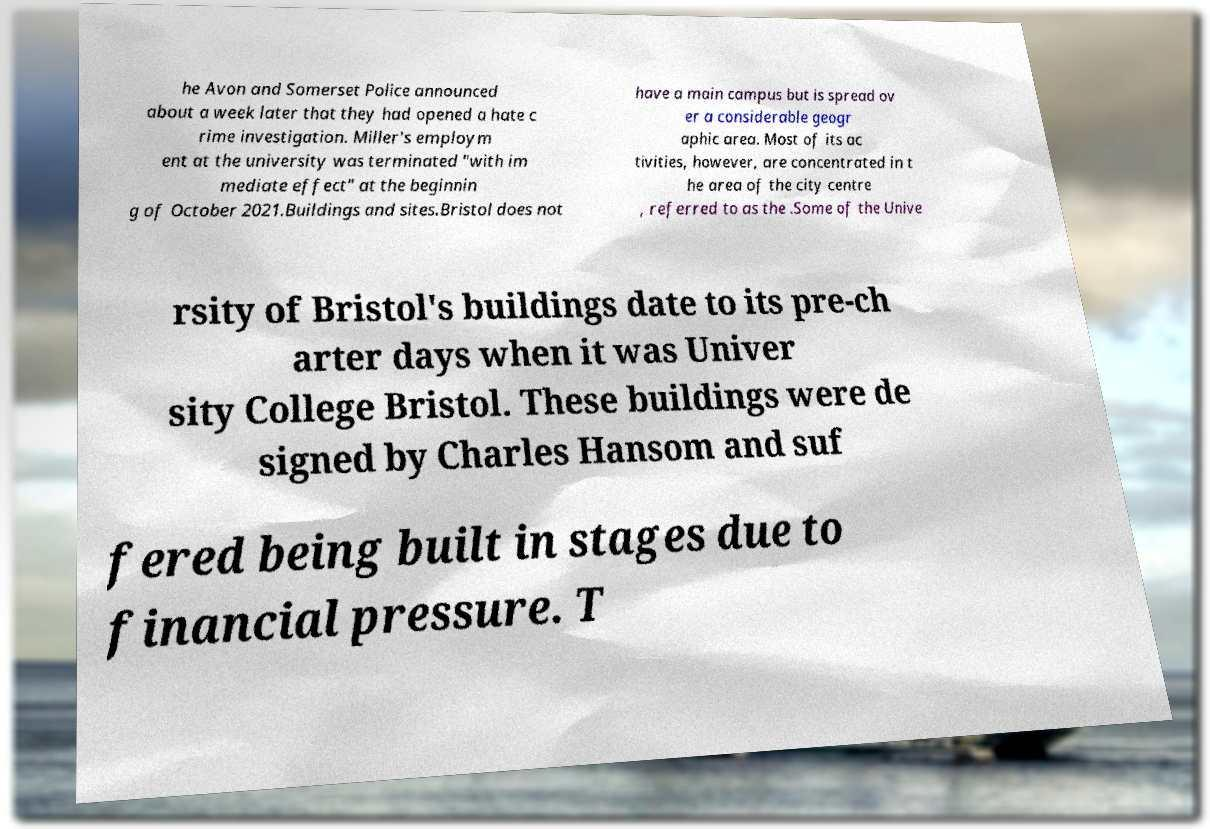Can you accurately transcribe the text from the provided image for me? he Avon and Somerset Police announced about a week later that they had opened a hate c rime investigation. Miller's employm ent at the university was terminated "with im mediate effect" at the beginnin g of October 2021.Buildings and sites.Bristol does not have a main campus but is spread ov er a considerable geogr aphic area. Most of its ac tivities, however, are concentrated in t he area of the city centre , referred to as the .Some of the Unive rsity of Bristol's buildings date to its pre-ch arter days when it was Univer sity College Bristol. These buildings were de signed by Charles Hansom and suf fered being built in stages due to financial pressure. T 